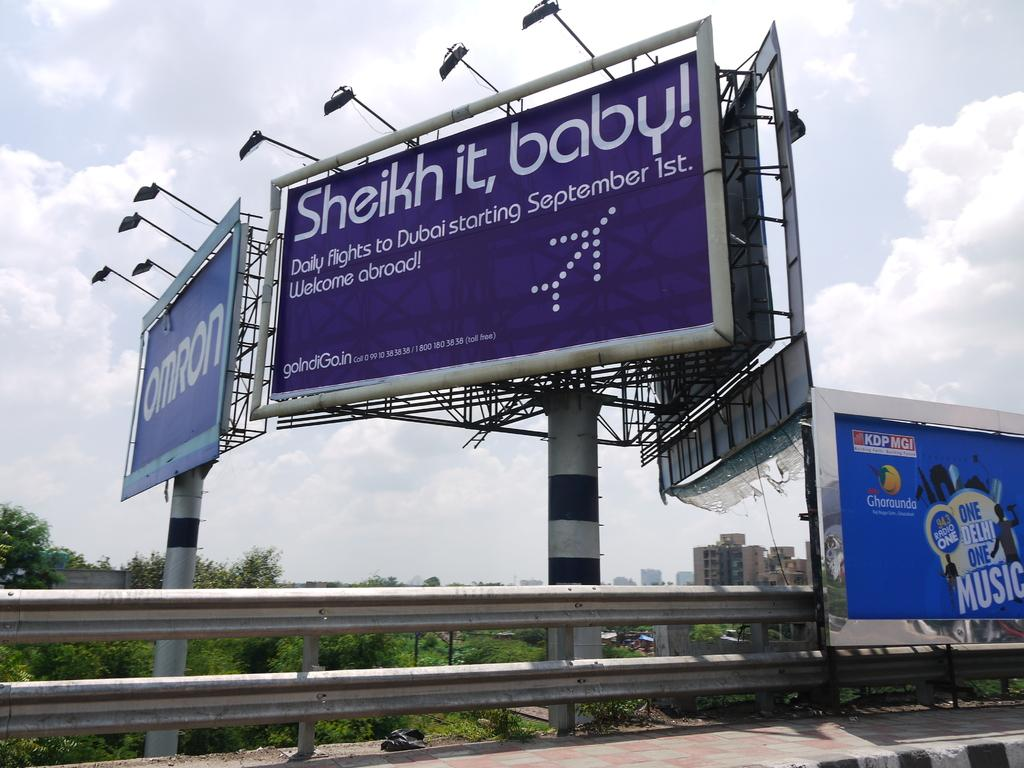<image>
Share a concise interpretation of the image provided. A large blue billboard is advertising daily flights to Dubai starting in September. 